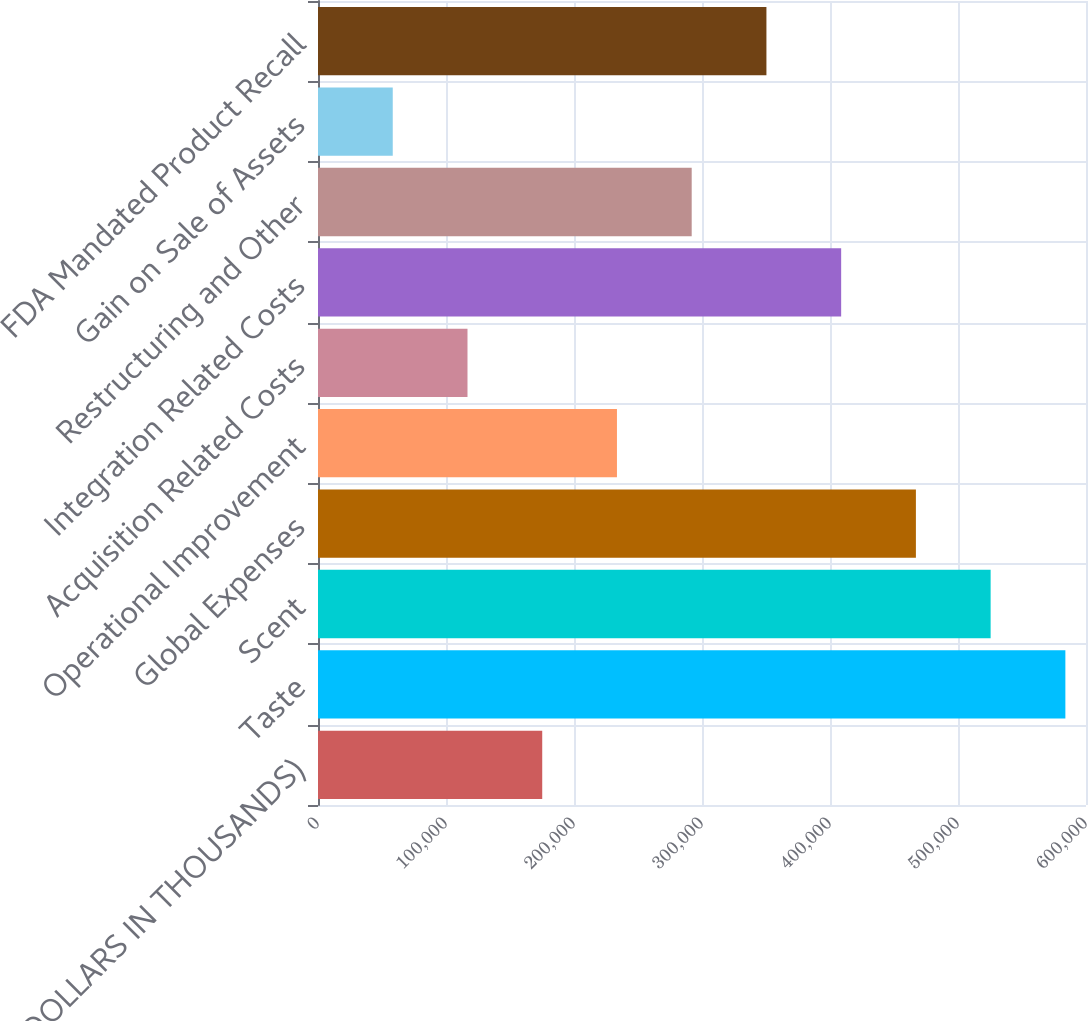<chart> <loc_0><loc_0><loc_500><loc_500><bar_chart><fcel>(DOLLARS IN THOUSANDS)<fcel>Taste<fcel>Scent<fcel>Global Expenses<fcel>Operational Improvement<fcel>Acquisition Related Costs<fcel>Integration Related Costs<fcel>Restructuring and Other<fcel>Gain on Sale of Assets<fcel>FDA Mandated Product Recall<nl><fcel>175175<fcel>583882<fcel>525495<fcel>467109<fcel>233562<fcel>116788<fcel>408722<fcel>291948<fcel>58401.4<fcel>350335<nl></chart> 